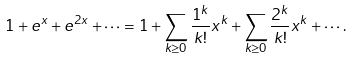Convert formula to latex. <formula><loc_0><loc_0><loc_500><loc_500>1 + e ^ { x } + e ^ { 2 x } + \cdots = 1 + \sum _ { k \geq 0 } \frac { 1 ^ { k } } { k ! } x ^ { k } + \sum _ { k \geq 0 } \frac { 2 ^ { k } } { k ! } x ^ { k } + \cdots .</formula> 